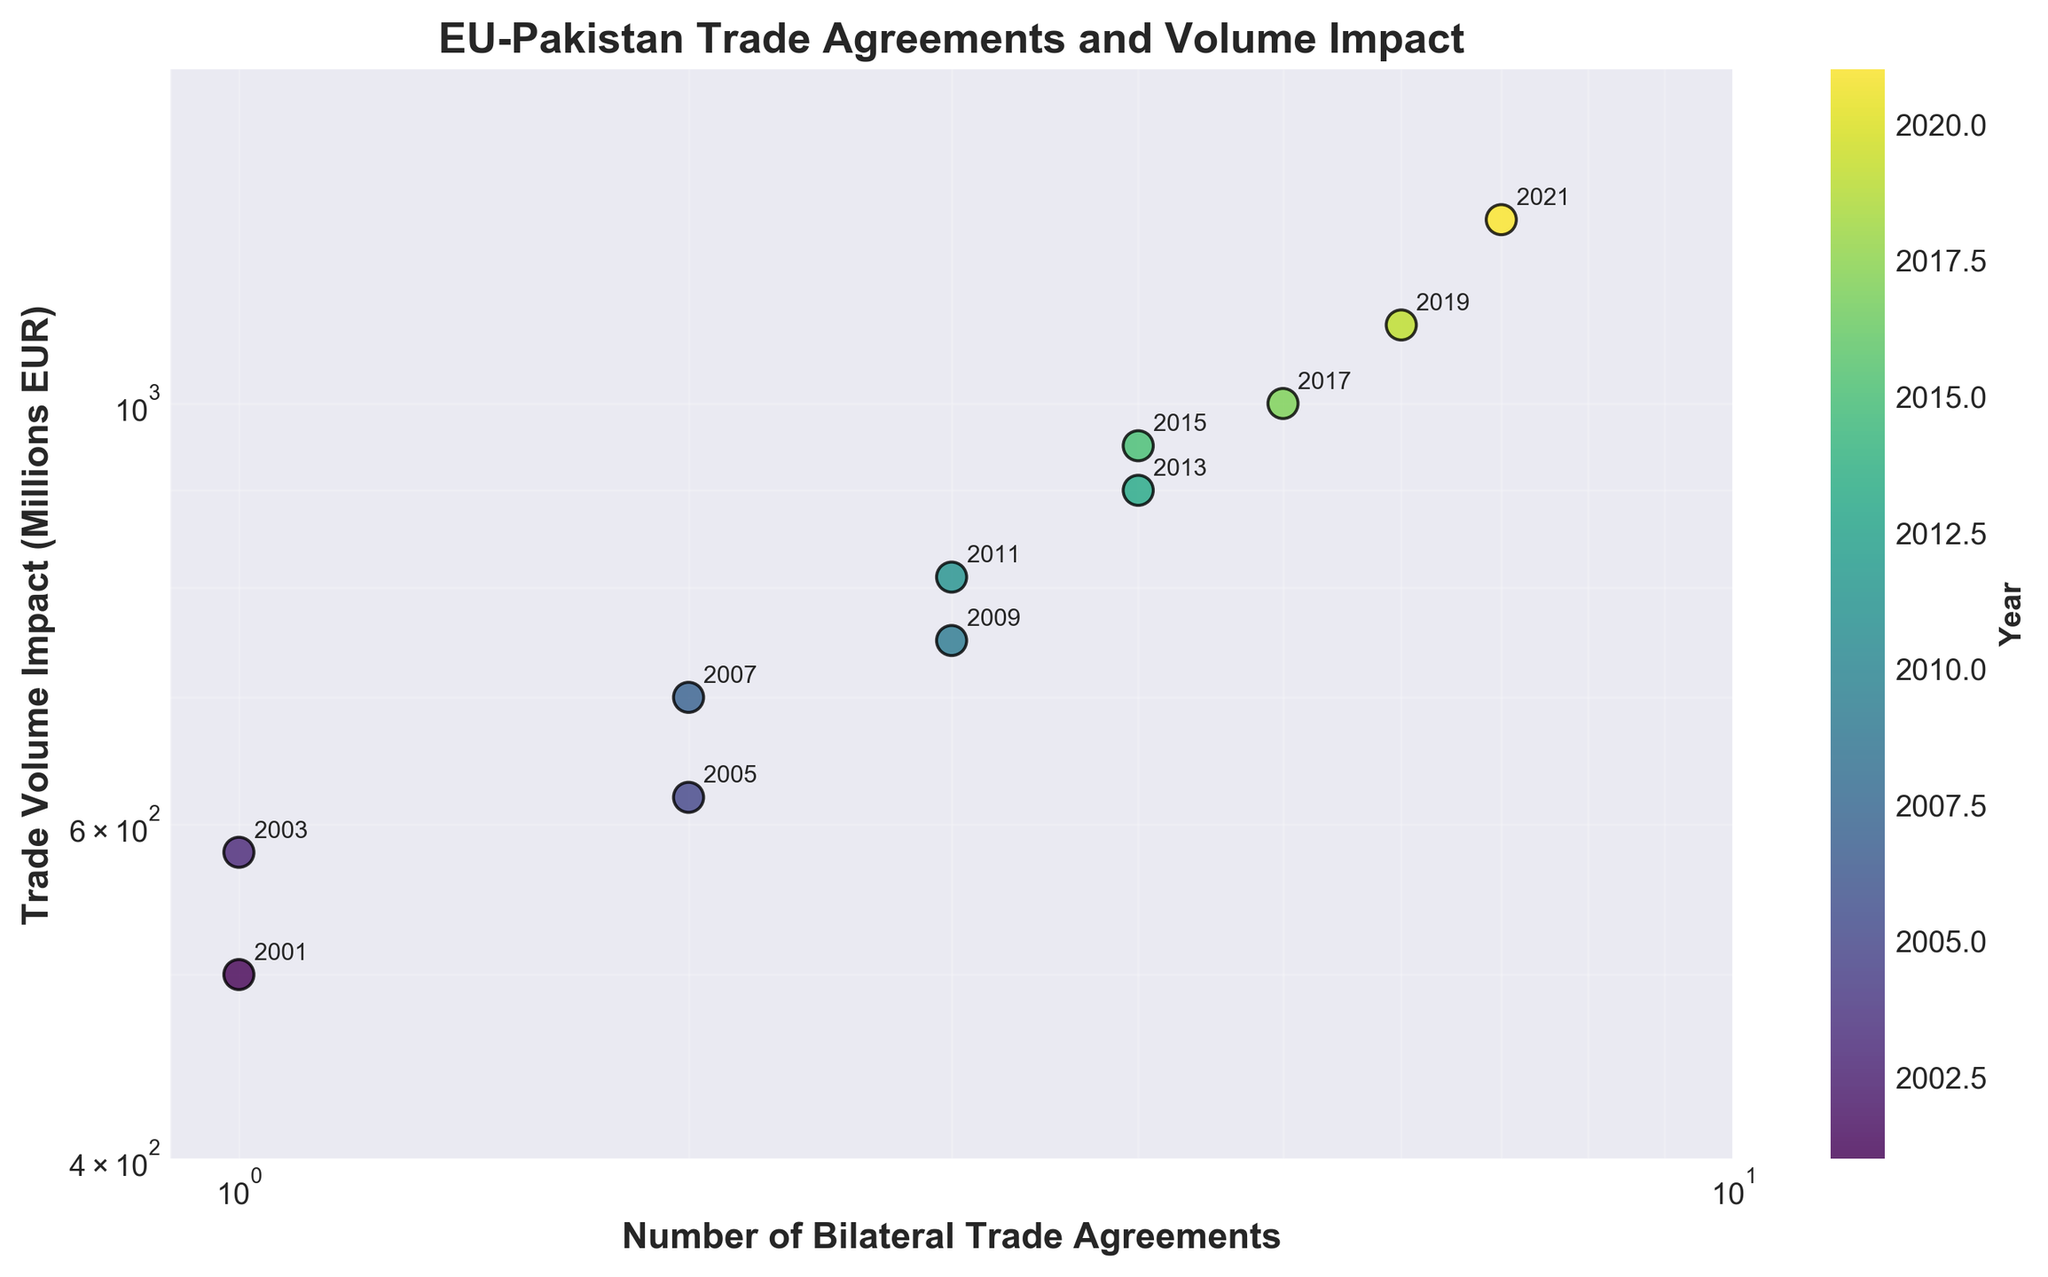What's the title of the figure? The title of a figure is usually displayed at the top or centrally above the plot. In this case, the title "EU-Pakistan Trade Agreements and Volume Impact" is displayed.
Answer: EU-Pakistan Trade Agreements and Volume Impact How many bilateral trade agreements were there in 2019? To find the number of trade agreements in 2019, locate the year 2019 on the color bar. According to the figure, 2019 is associated with 6 bilateral trade agreements.
Answer: 6 Which year had the highest trade volume impact? To identify the year with the highest trade volume impact, find the point that is located highest on the y-axis. In this case, the year 2021 is associated with the highest trade volume impact of 1250 million EUR.
Answer: 2021 What is the trade volume impact in 2005? Locate the year 2005 on the annotated data points. The point corresponding to 2005 has a trade volume impact of 620 million EUR as indicated on the y-axis.
Answer: 620 million EUR How many bilateral trade agreements were signed by 2011? Sum the number of agreements from 2001 to 2011 by identifying the data points on the plot. The years 2001, 2003, 2005, 2007, 2009, and 2011 have a cumulative total of 1 + 1 + 2 + 2 + 3 + 3 = 12 agreements. However, note that some years share the same number of agreements, so it should be counted 1, 2, 3 which totals to 3 only.
Answer: 3 What is the main trend depicted in the scatter plot? Observing the overall pattern in the data points, the number of bilateral trade agreements and the corresponding trade volume impact tend to increase over the years, showing a positive correlation between the two.
Answer: Increasing trend How did the trade volume impact change from 2015 to 2019? Identify the points for the years 2015 and 2019. The trade volume impact for 2015 is 950 million EUR and for 2019 is 1100 million EUR. Calculating the change, 1100 - 950 = 150 million EUR increase.
Answer: Increased by 150 million EUR What can be inferred about the relationship between the number of bilateral trade agreements and trade volume impact? By observing the scatter plot with the x-axis (number of agreements) and the y-axis (trade volume impact), it can be inferred that there is a positive correlation, as more agreements generally relate to higher trade volume impact.
Answer: Positive correlation Which two consecutive years had the smallest increase in trade volume impact? Closely inspect the annotated points and their corresponding y-axis values to find the smallest difference. The years 2013 (900) and 2015 (950) have an increase of 50 million EUR, which is the smallest.
Answer: 2013 and 2015 What does the color of the points represent? The color bar on the right side of the figure indicates that the color of the points represents the year. Different shades represent different years.
Answer: Year 